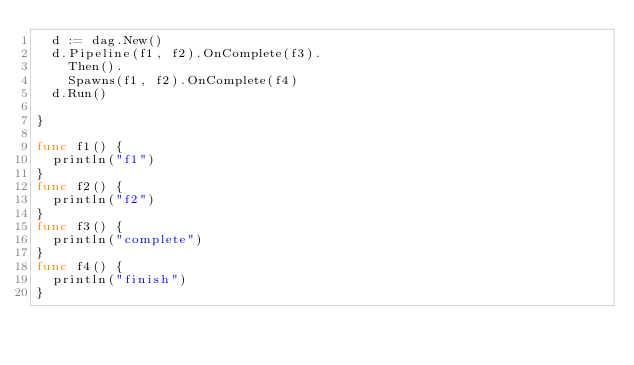<code> <loc_0><loc_0><loc_500><loc_500><_Go_>	d := dag.New()
	d.Pipeline(f1, f2).OnComplete(f3).
		Then().
		Spawns(f1, f2).OnComplete(f4)
	d.Run()

}

func f1() {
	println("f1")
}
func f2() {
	println("f2")
}
func f3() {
	println("complete")
}
func f4() {
	println("finish")
}
</code> 